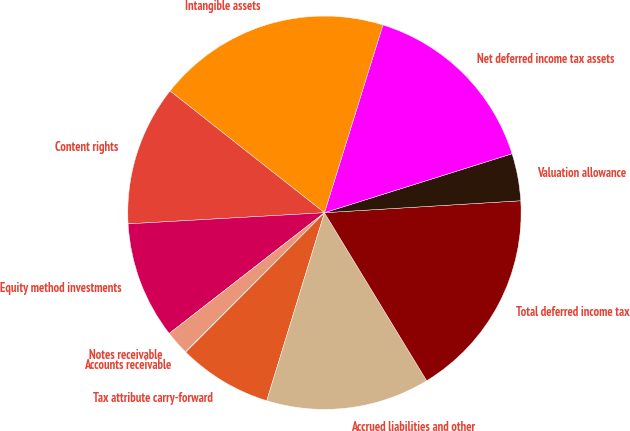<chart> <loc_0><loc_0><loc_500><loc_500><pie_chart><fcel>Accounts receivable<fcel>Tax attribute carry-forward<fcel>Accrued liabilities and other<fcel>Total deferred income tax<fcel>Valuation allowance<fcel>Net deferred income tax assets<fcel>Intangible assets<fcel>Content rights<fcel>Equity method investments<fcel>Notes receivable<nl><fcel>0.06%<fcel>7.71%<fcel>13.44%<fcel>17.27%<fcel>3.88%<fcel>15.35%<fcel>19.18%<fcel>11.53%<fcel>9.62%<fcel>1.97%<nl></chart> 